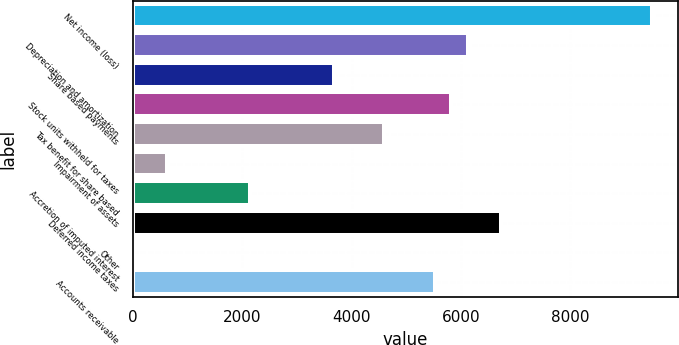Convert chart to OTSL. <chart><loc_0><loc_0><loc_500><loc_500><bar_chart><fcel>Net income (loss)<fcel>Depreciation and amortization<fcel>Share based payments<fcel>Stock units withheld for taxes<fcel>Tax benefit for share based<fcel>Impairment of assets<fcel>Accretion of imputed interest<fcel>Deferred income taxes<fcel>Other<fcel>Accounts receivable<nl><fcel>9503.5<fcel>6132<fcel>3680<fcel>5825.5<fcel>4599.5<fcel>615<fcel>2147.5<fcel>6745<fcel>2<fcel>5519<nl></chart> 